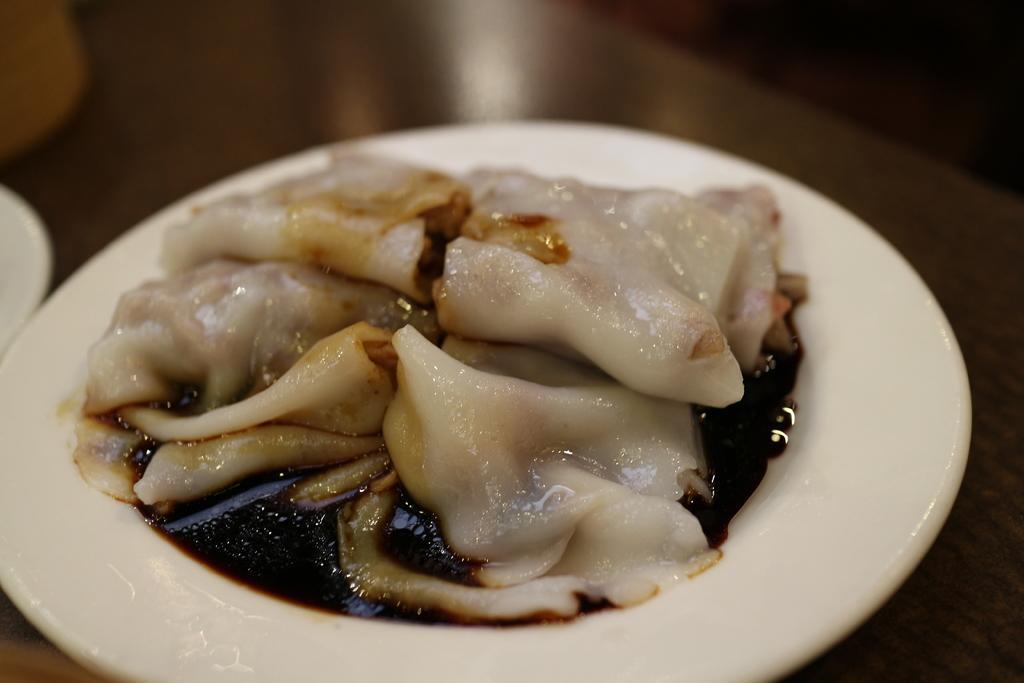Could you give a brief overview of what you see in this image? In this image we can see a plate with a food item. And the plate is on a surface. 